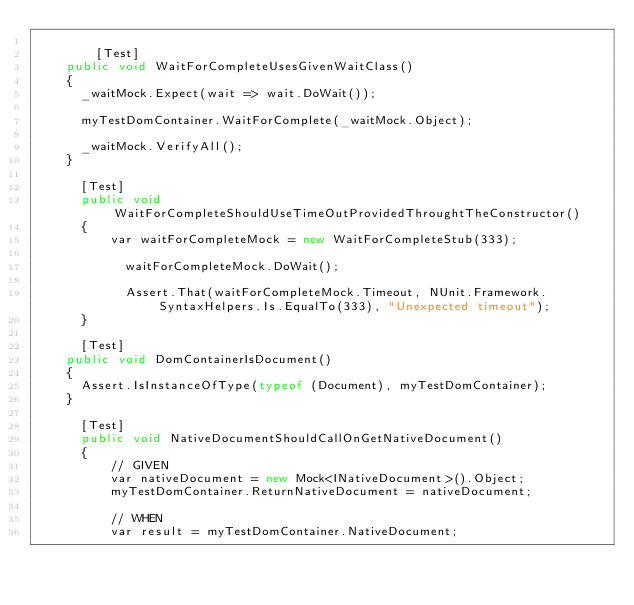<code> <loc_0><loc_0><loc_500><loc_500><_C#_>
        [Test]
		public void WaitForCompleteUsesGivenWaitClass()
		{
			_waitMock.Expect(wait => wait.DoWait());

			myTestDomContainer.WaitForComplete(_waitMock.Object);

			_waitMock.VerifyAll();
		}

	    [Test]
	    public void WaitForCompleteShouldUseTimeOutProvidedThroughtTheConstructor()
	    {
	        var waitForCompleteMock = new WaitForCompleteStub(333);

            waitForCompleteMock.DoWait();
            
            Assert.That(waitForCompleteMock.Timeout, NUnit.Framework.SyntaxHelpers.Is.EqualTo(333), "Unexpected timeout");
	    }

	    [Test]
		public void DomContainerIsDocument()
		{
			Assert.IsInstanceOfType(typeof (Document), myTestDomContainer);
		}

	    [Test]
	    public void NativeDocumentShouldCallOnGetNativeDocument()
	    {
	        // GIVEN
	        var nativeDocument = new Mock<INativeDocument>().Object;
	        myTestDomContainer.ReturnNativeDocument = nativeDocument;

	        // WHEN
	        var result = myTestDomContainer.NativeDocument;
</code> 